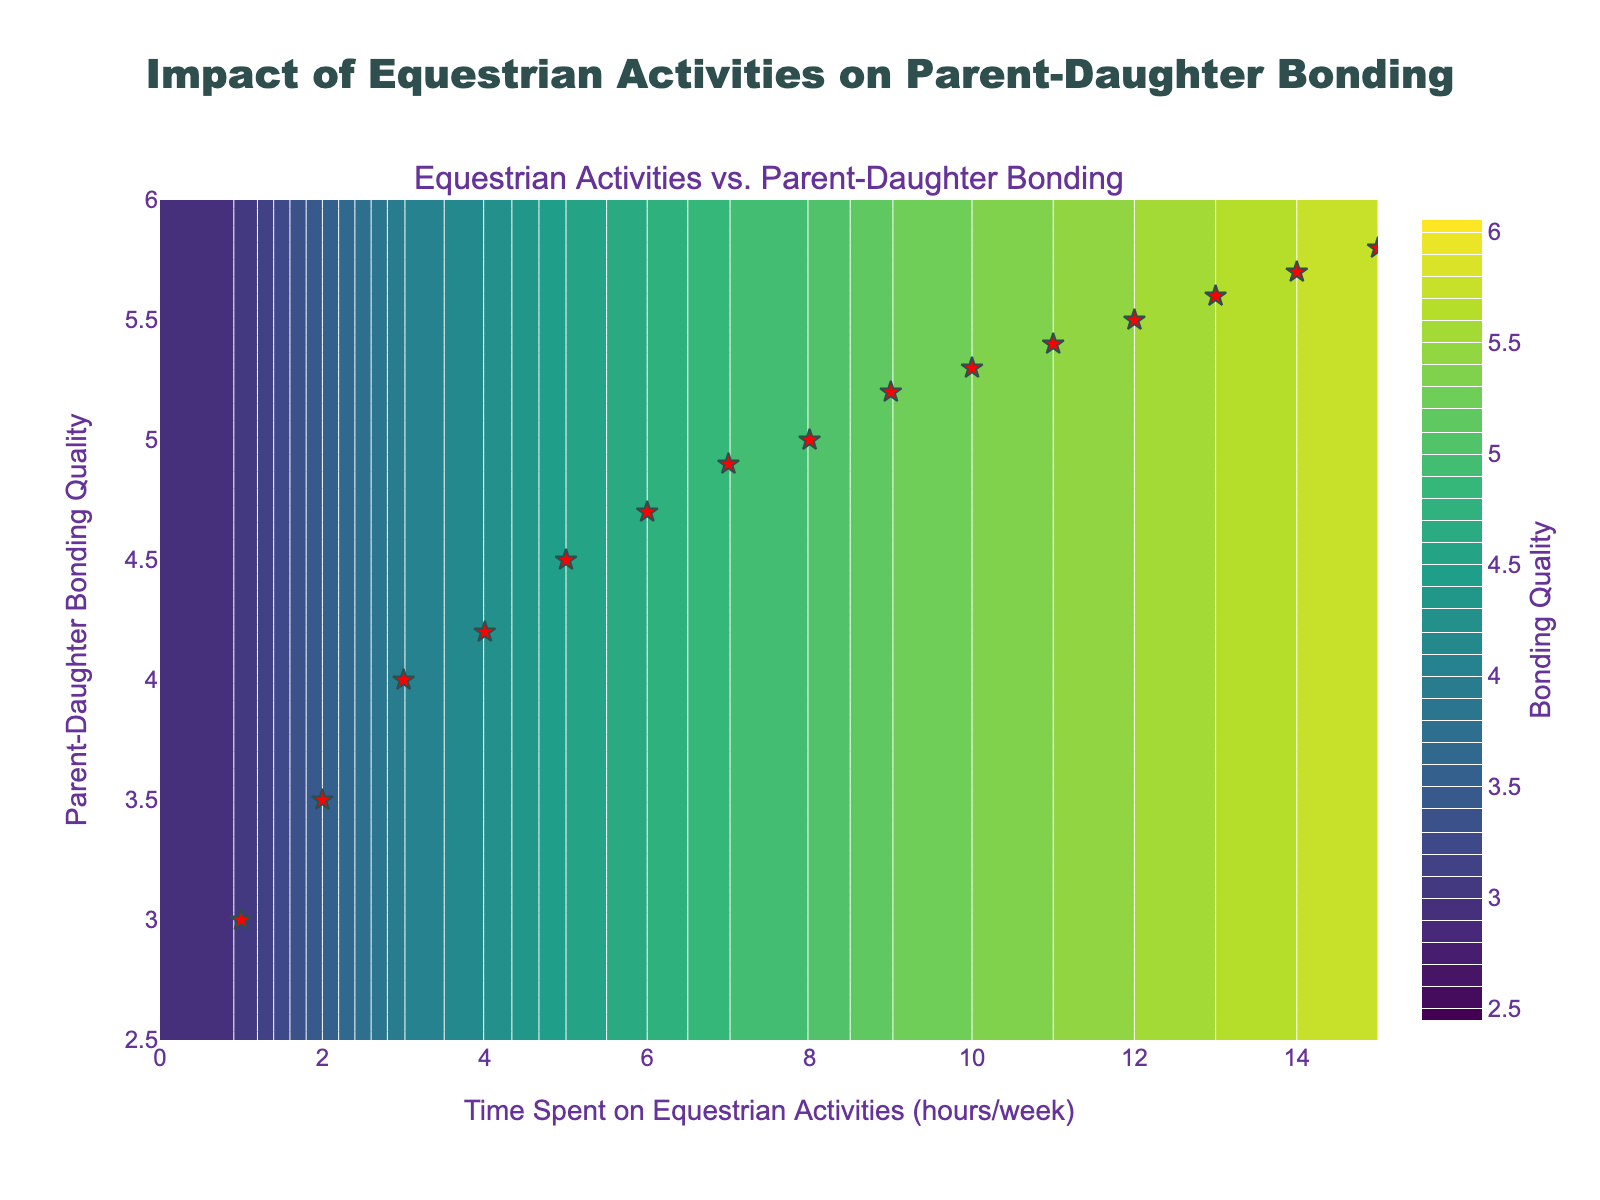What is the title of the plot? The title of the plot is usually placed at the top center of the figure. In this case, it reads "Impact of Equestrian Activities on Parent-Daughter Bonding".
Answer: Impact of Equestrian Activities on Parent-Daughter Bonding What do the x and y axes represent? The x-axis label usually appears below the horizontal axis, and the y-axis label appears to the left of the vertical axis. In this plot, the x-axis represents "Time Spent on Equestrian Activities (hours/week)", and the y-axis represents "Parent-Daughter Bonding Quality".
Answer: Time Spent on Equestrian Activities (hours/week) and Parent-Daughter Bonding Quality How many marked data points are there on the scatter plot? The scatter plot markers are visible as red stars on the plot. By counting these visible markers, we find there are 15 data points.
Answer: 15 At roughly what time spent on equestrian activities does the Parent-Daughter Bonding Quality reach 5? To determine moments when the Parent-Daughter Bonding Quality reaches 5, we look at where the contour line intersects with the y-axis value near 5. It appears this happens around 8 and 9 hours per week.
Answer: 8-9 hours per week What color scheme is used in the contour plot, and what does it indicate? The contour plot uses the 'Viridis' color scheme, which ranges from dark purple to bright yellow. This color gradient indicates the quality of bonding, with darker colors representing lower quality and lighter colors representing higher quality.
Answer: Viridis color scheme indicating bonding quality How does the bonding quality change with increased time spent on equestrian activities? The contour lines and the scatter plot trend suggest that as time spent on equestrian activities increases, the Parent-Daughter Bonding Quality also increases. This is visually corroborated by the positive slope of the scatter plot points.
Answer: It increases What is the initial bonding quality when time spent on equestrian activities is zero? While the plot doesn't explicitly show time spent at zero hours, we can infer from the trend starting from 1 hour where the quality is about 3. Thus, bonding quality starts around 2.5-3.
Answer: Around 2.5-3 What is the rate of change in bonding quality from 5 to 10 hours of equestrian activities per week? To find the rate of change, we look at the difference in bonding quality between these two points (5.3 at 10 hours and 4.5 at 5 hours) and divide by the change in hours (5 hours). The rate of change is (5.3-4.5)/5 = 0.16 per hour.
Answer: 0.16 per hour Between what bonding quality values do the majority of data points fall? By observing the scatter plot, most data points are between bonding qualities of 4 and 5.5 showing that the majority lie within this range.
Answer: Between 4 and 5.5 Which area in the contour plot has the densest collection of higher bonding quality? The density of a contour can be understood by closely packed contour lines and the color gradient; the area with the lightest (bright yellow) hues towards the top of the y-axis indicates the highest bonding quality, especially past 10 hours/week on the x-axis.
Answer: Past 10 hours/week with bonding quality around 5.5+ 